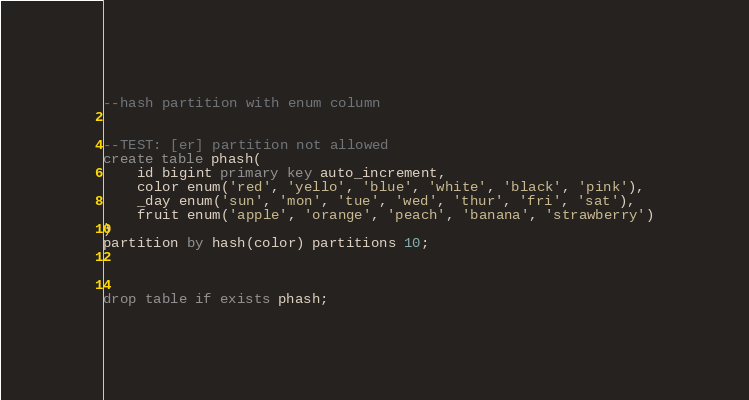<code> <loc_0><loc_0><loc_500><loc_500><_SQL_>--hash partition with enum column


--TEST: [er] partition not allowed
create table phash(
	id bigint primary key auto_increment,
	color enum('red', 'yello', 'blue', 'white', 'black', 'pink'),
	_day enum('sun', 'mon', 'tue', 'wed', 'thur', 'fri', 'sat'),
	fruit enum('apple', 'orange', 'peach', 'banana', 'strawberry')
)
partition by hash(color) partitions 10;



drop table if exists phash;


</code> 